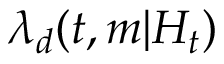<formula> <loc_0><loc_0><loc_500><loc_500>\lambda _ { d } ( t , m | H _ { t } )</formula> 